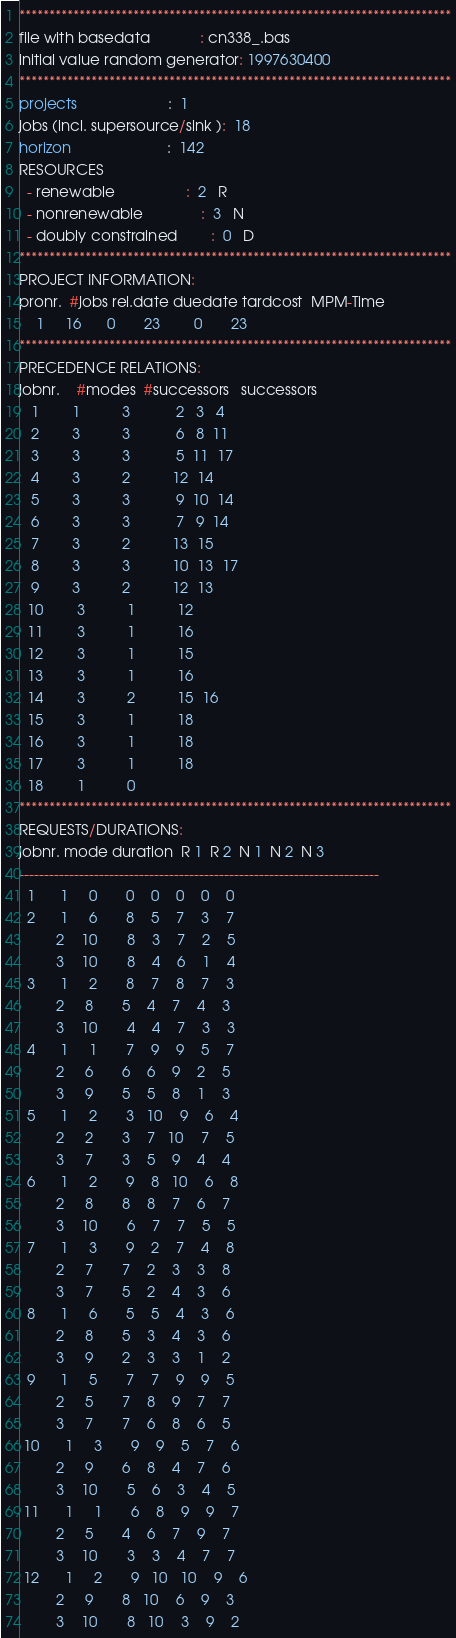Convert code to text. <code><loc_0><loc_0><loc_500><loc_500><_ObjectiveC_>************************************************************************
file with basedata            : cn338_.bas
initial value random generator: 1997630400
************************************************************************
projects                      :  1
jobs (incl. supersource/sink ):  18
horizon                       :  142
RESOURCES
  - renewable                 :  2   R
  - nonrenewable              :  3   N
  - doubly constrained        :  0   D
************************************************************************
PROJECT INFORMATION:
pronr.  #jobs rel.date duedate tardcost  MPM-Time
    1     16      0       23        0       23
************************************************************************
PRECEDENCE RELATIONS:
jobnr.    #modes  #successors   successors
   1        1          3           2   3   4
   2        3          3           6   8  11
   3        3          3           5  11  17
   4        3          2          12  14
   5        3          3           9  10  14
   6        3          3           7   9  14
   7        3          2          13  15
   8        3          3          10  13  17
   9        3          2          12  13
  10        3          1          12
  11        3          1          16
  12        3          1          15
  13        3          1          16
  14        3          2          15  16
  15        3          1          18
  16        3          1          18
  17        3          1          18
  18        1          0        
************************************************************************
REQUESTS/DURATIONS:
jobnr. mode duration  R 1  R 2  N 1  N 2  N 3
------------------------------------------------------------------------
  1      1     0       0    0    0    0    0
  2      1     6       8    5    7    3    7
         2    10       8    3    7    2    5
         3    10       8    4    6    1    4
  3      1     2       8    7    8    7    3
         2     8       5    4    7    4    3
         3    10       4    4    7    3    3
  4      1     1       7    9    9    5    7
         2     6       6    6    9    2    5
         3     9       5    5    8    1    3
  5      1     2       3   10    9    6    4
         2     2       3    7   10    7    5
         3     7       3    5    9    4    4
  6      1     2       9    8   10    6    8
         2     8       8    8    7    6    7
         3    10       6    7    7    5    5
  7      1     3       9    2    7    4    8
         2     7       7    2    3    3    8
         3     7       5    2    4    3    6
  8      1     6       5    5    4    3    6
         2     8       5    3    4    3    6
         3     9       2    3    3    1    2
  9      1     5       7    7    9    9    5
         2     5       7    8    9    7    7
         3     7       7    6    8    6    5
 10      1     3       9    9    5    7    6
         2     9       6    8    4    7    6
         3    10       5    6    3    4    5
 11      1     1       6    8    9    9    7
         2     5       4    6    7    9    7
         3    10       3    3    4    7    7
 12      1     2       9   10   10    9    6
         2     9       8   10    6    9    3
         3    10       8   10    3    9    2</code> 